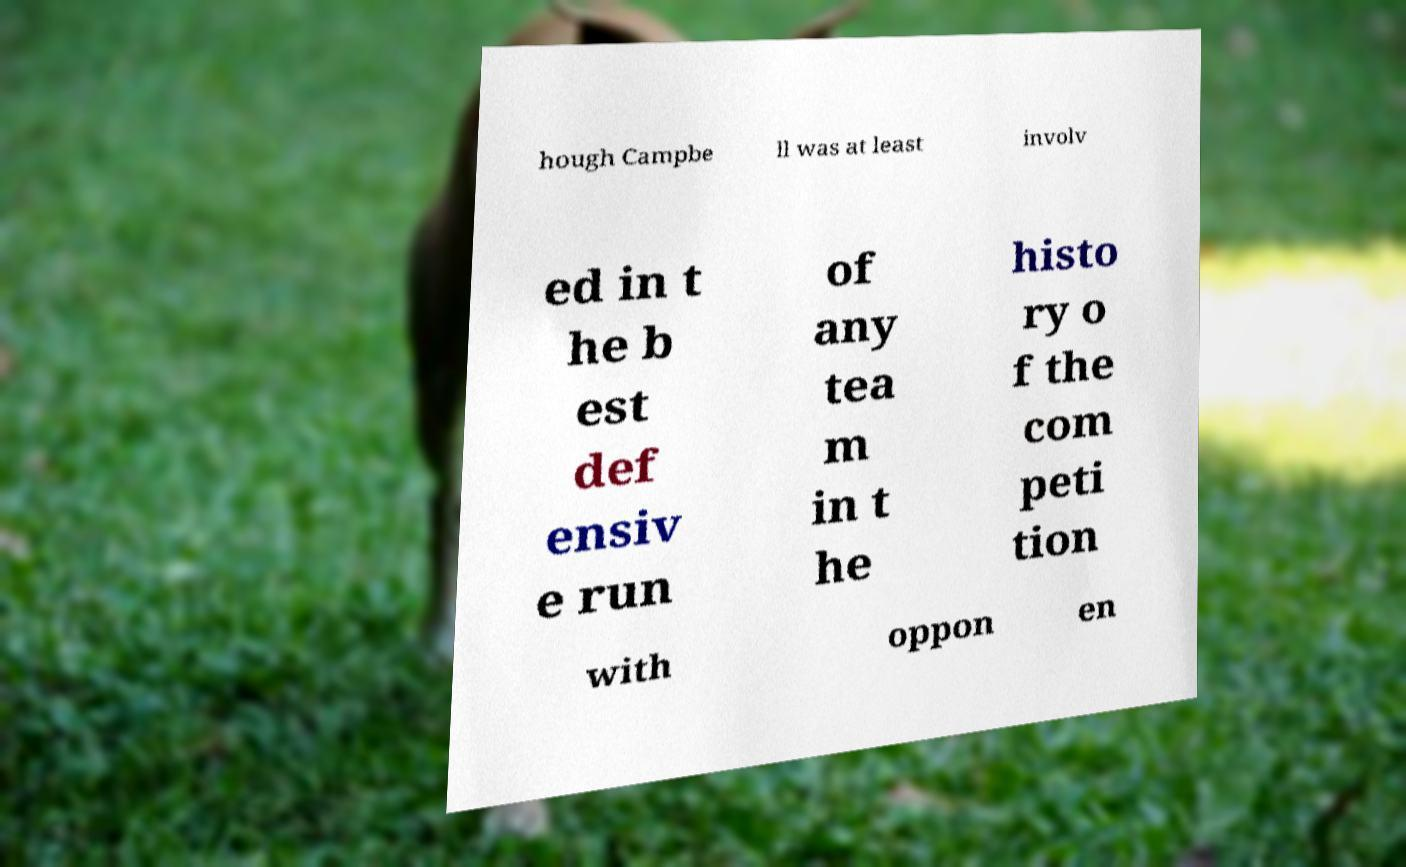Please read and relay the text visible in this image. What does it say? hough Campbe ll was at least involv ed in t he b est def ensiv e run of any tea m in t he histo ry o f the com peti tion with oppon en 